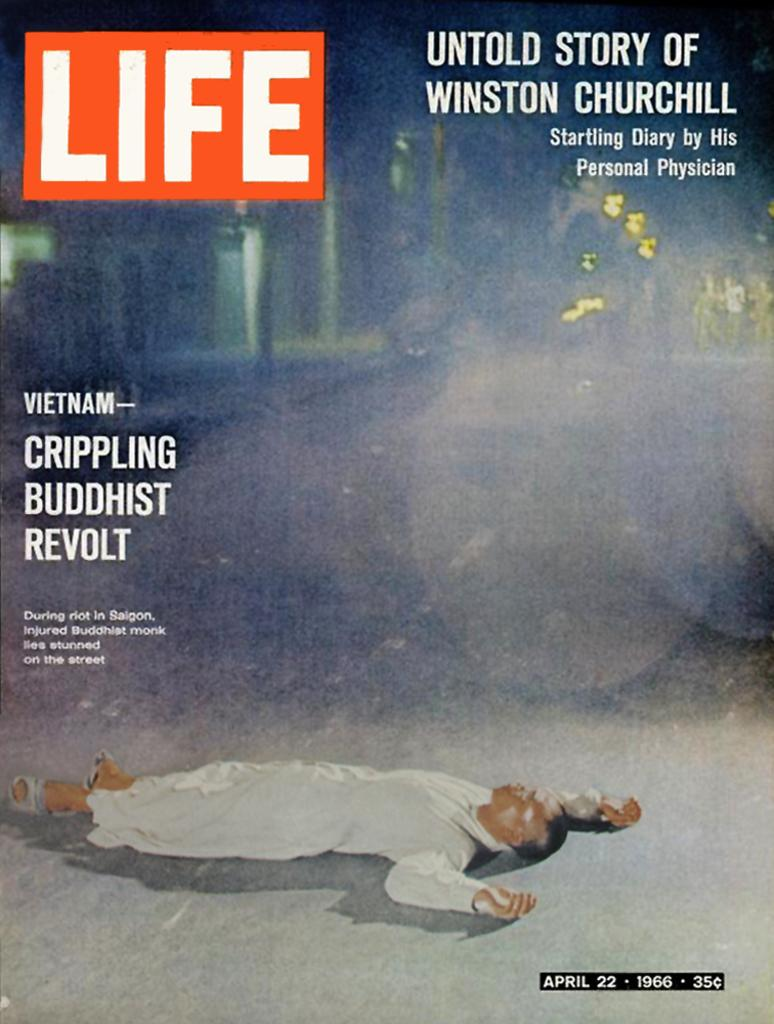What is present in the image? There is a poster in the image. What is depicted on the poster? The poster features a person lying on a surface. Are there any words or phrases on the poster? Yes, there is text on the poster. What type of holiday is being celebrated in the wilderness depicted on the poster? There is no wilderness or holiday depicted on the poster; it features a person lying on a surface with text. 